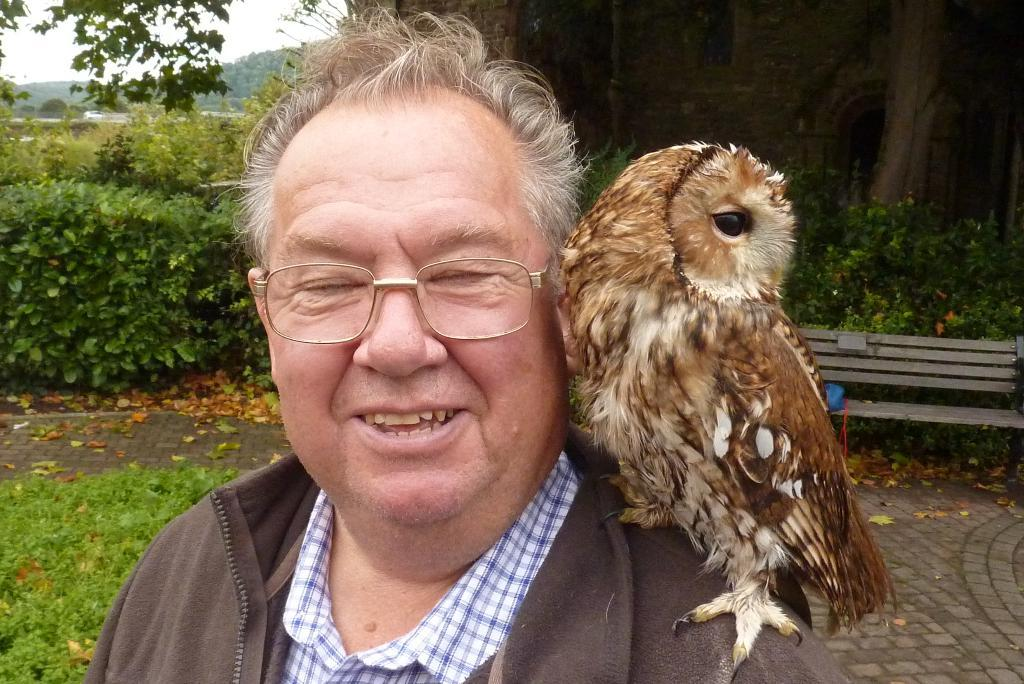Who is present in the image? There is a man in the image. What is the man wearing? The man is wearing a brown color jacket. Are there any accessories visible on the man? Yes, the man is wearing glasses (specs). What is the unusual feature about the man in the image? There is an owl on the man's shoulder. What can be seen in the background of the image? There are plants visible in the background of the image. What type of waste can be seen in the image? There is no waste present in the image. What drug is the man taking in the image? There is no drug present in the image, and the man is not taking any medication. 